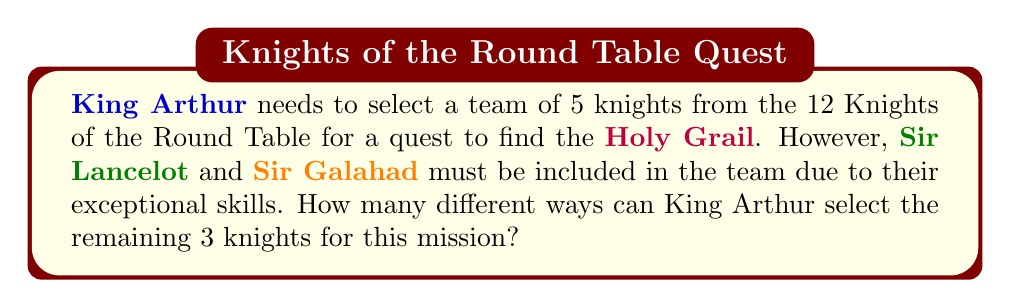Teach me how to tackle this problem. Let's approach this step-by-step:

1) First, we need to recognize that this is a combination problem. We are selecting knights without regard to order (the order in which they are chosen doesn't matter).

2) We are told that Sir Lancelot and Sir Galahad must be included. This means we have already filled 2 of the 5 positions in the team.

3) We need to select the remaining 3 knights from the other 10 knights (12 total - 2 already selected = 10 remaining).

4) This scenario can be represented by the combination formula:

   $$C(n,r) = \frac{n!}{r!(n-r)!}$$

   Where $n$ is the number of items to choose from, and $r$ is the number of items being chosen.

5) In this case, $n = 10$ (the remaining knights to choose from) and $r = 3$ (the number of knights we need to select).

6) Plugging these numbers into our formula:

   $$C(10,3) = \frac{10!}{3!(10-3)!} = \frac{10!}{3!7!}$$

7) Expanding this:
   
   $$\frac{10 * 9 * 8 * 7!}{(3 * 2 * 1) * 7!}$$

8) The 7! cancels out in the numerator and denominator:

   $$\frac{10 * 9 * 8}{3 * 2 * 1} = \frac{720}{6} = 120$$

Therefore, there are 120 different ways to select the remaining 3 knights for the mission.
Answer: 120 